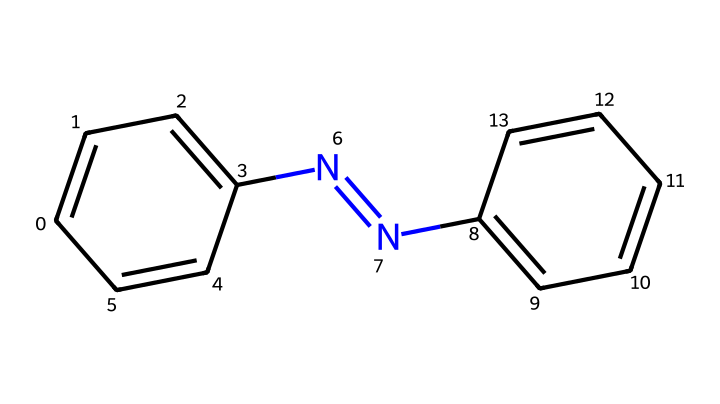What is the molecular formula of azobenzene? The SMILES representation indicates the presence of two benzene rings and two nitrogen atoms in a structural arrangement. By counting the atoms in the structure, it's determined that the molecular formula is C12H10N2.
Answer: C12H10N2 How many rings are present in azobenzene? Analyzing the structure depicted in the SMILES, it is clear that there are two aromatic rings formed by the carbon atoms in the structure, specifically two phenyl groups connected by a nitrogen-nitrogen double bond.
Answer: 2 What type of bond connects the two nitrogen atoms in azobenzene? In the representation, the N=N bond indicates a double bond between the two nitrogen atoms. This is a specific feature of azo compounds, characterizing the bonding nature in azobenzene.
Answer: double bond What is the significance of the N=N bond in azobenzene? The N=N bond in azobenzene is crucial as it allows the compound to undergo isomerization upon light exposure, which is a key characteristic of photoreactive chemicals. This property is utilized in optical data storage.
Answer: isomerization How does azobenzene respond to light exposure? Azobenzene, upon exposure to ultraviolet light, undergoes a transformation from its trans form to the cis form. This change alters its physical properties and is critical for applications in materials science and optical data storage.
Answer: cis-trans isomerization What are the common applications of azobenzene? Due to its photoswitchable properties, azobenzene is commonly used in optical data storage, molecular switches, and photonic devices, leveraging its ability to change configuration with light.
Answer: optical data storage 